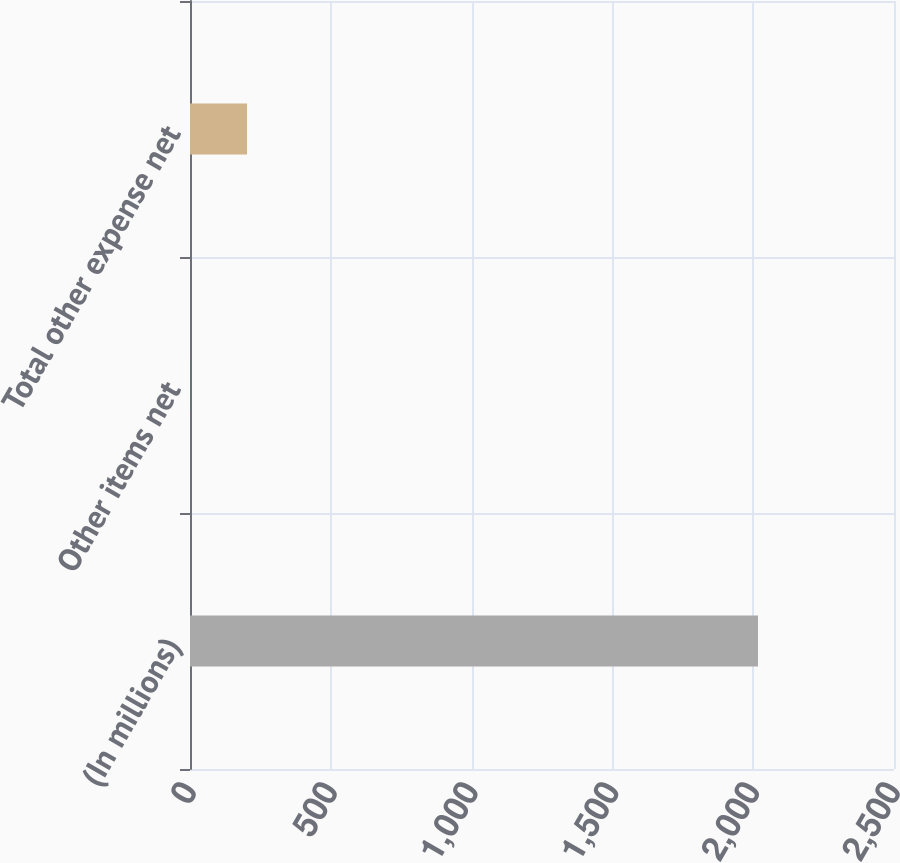<chart> <loc_0><loc_0><loc_500><loc_500><bar_chart><fcel>(In millions)<fcel>Other items net<fcel>Total other expense net<nl><fcel>2017<fcel>0.9<fcel>202.51<nl></chart> 